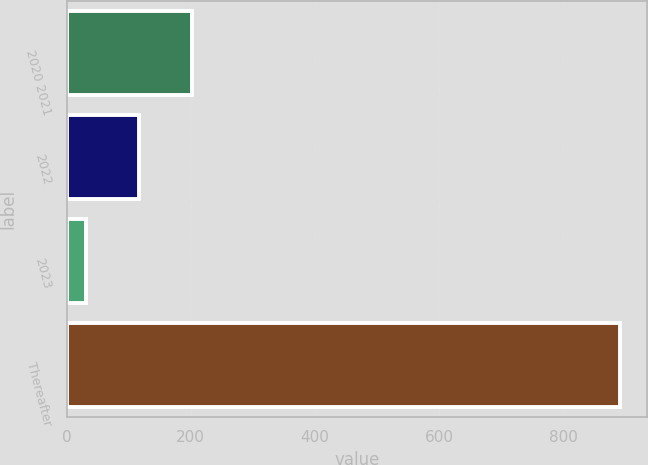<chart> <loc_0><loc_0><loc_500><loc_500><bar_chart><fcel>2020 2021<fcel>2022<fcel>2023<fcel>Thereafter<nl><fcel>202.8<fcel>116.8<fcel>30.8<fcel>890.8<nl></chart> 